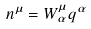<formula> <loc_0><loc_0><loc_500><loc_500>n ^ { \mu } = W ^ { \mu } _ { \alpha } q ^ { \alpha }</formula> 